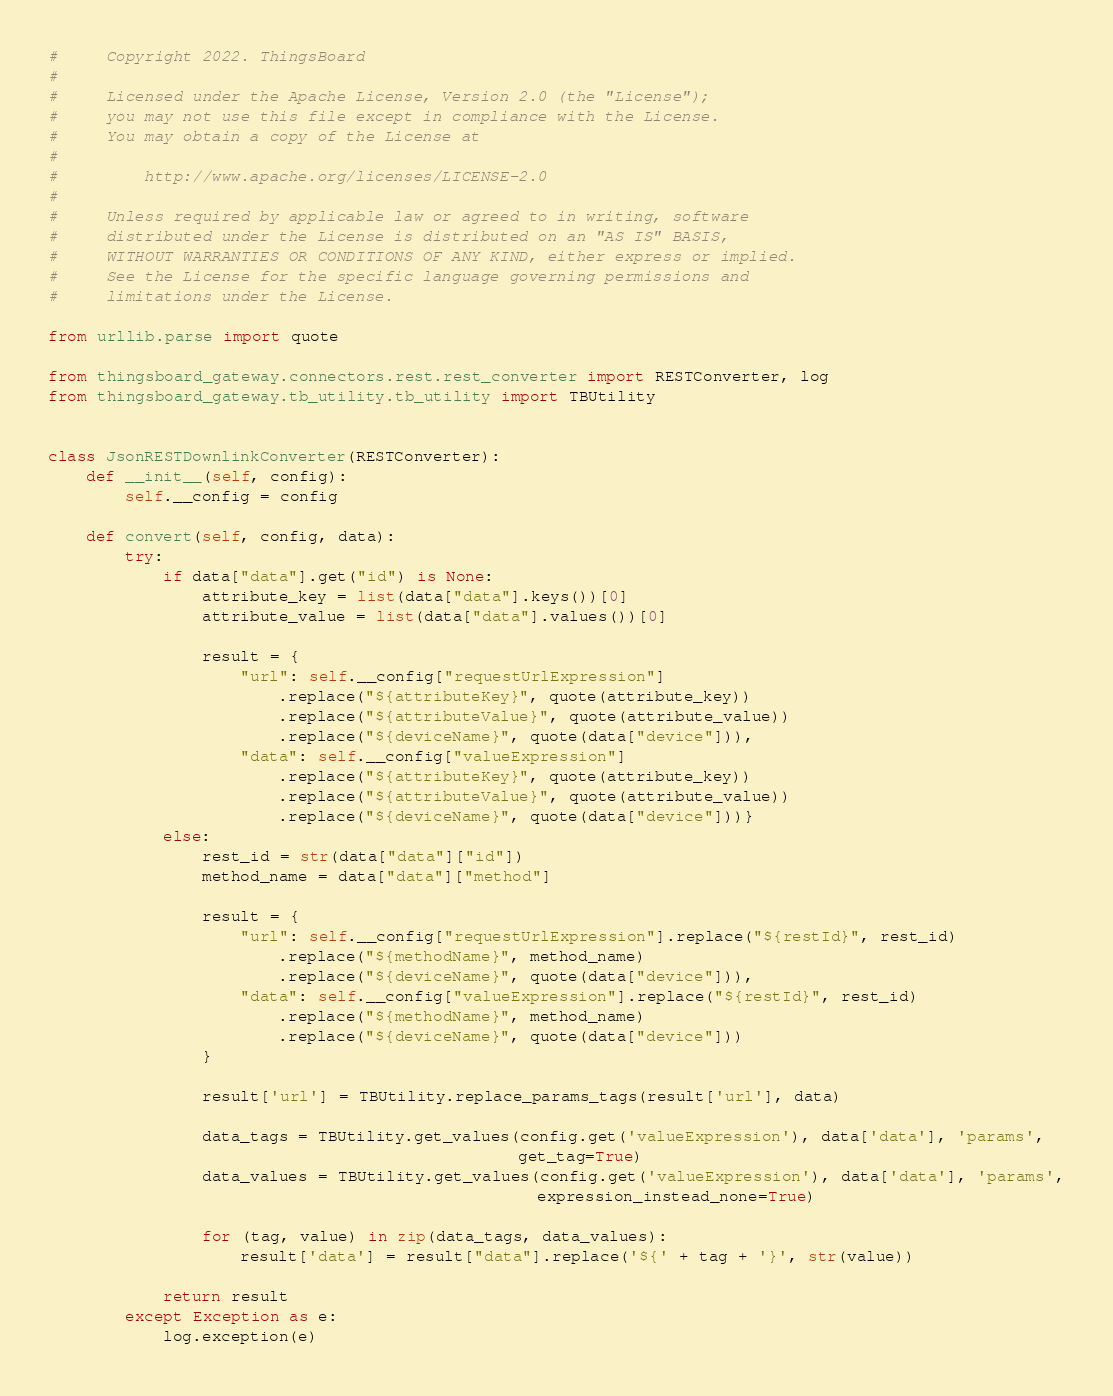Convert code to text. <code><loc_0><loc_0><loc_500><loc_500><_Python_>#     Copyright 2022. ThingsBoard
#
#     Licensed under the Apache License, Version 2.0 (the "License");
#     you may not use this file except in compliance with the License.
#     You may obtain a copy of the License at
#
#         http://www.apache.org/licenses/LICENSE-2.0
#
#     Unless required by applicable law or agreed to in writing, software
#     distributed under the License is distributed on an "AS IS" BASIS,
#     WITHOUT WARRANTIES OR CONDITIONS OF ANY KIND, either express or implied.
#     See the License for the specific language governing permissions and
#     limitations under the License.

from urllib.parse import quote

from thingsboard_gateway.connectors.rest.rest_converter import RESTConverter, log
from thingsboard_gateway.tb_utility.tb_utility import TBUtility


class JsonRESTDownlinkConverter(RESTConverter):
    def __init__(self, config):
        self.__config = config

    def convert(self, config, data):
        try:
            if data["data"].get("id") is None:
                attribute_key = list(data["data"].keys())[0]
                attribute_value = list(data["data"].values())[0]

                result = {
                    "url": self.__config["requestUrlExpression"]
                        .replace("${attributeKey}", quote(attribute_key))
                        .replace("${attributeValue}", quote(attribute_value))
                        .replace("${deviceName}", quote(data["device"])),
                    "data": self.__config["valueExpression"]
                        .replace("${attributeKey}", quote(attribute_key))
                        .replace("${attributeValue}", quote(attribute_value))
                        .replace("${deviceName}", quote(data["device"]))}
            else:
                rest_id = str(data["data"]["id"])
                method_name = data["data"]["method"]

                result = {
                    "url": self.__config["requestUrlExpression"].replace("${restId}", rest_id)
                        .replace("${methodName}", method_name)
                        .replace("${deviceName}", quote(data["device"])),
                    "data": self.__config["valueExpression"].replace("${restId}", rest_id)
                        .replace("${methodName}", method_name)
                        .replace("${deviceName}", quote(data["device"]))
                }

                result['url'] = TBUtility.replace_params_tags(result['url'], data)

                data_tags = TBUtility.get_values(config.get('valueExpression'), data['data'], 'params',
                                                 get_tag=True)
                data_values = TBUtility.get_values(config.get('valueExpression'), data['data'], 'params',
                                                   expression_instead_none=True)

                for (tag, value) in zip(data_tags, data_values):
                    result['data'] = result["data"].replace('${' + tag + '}', str(value))

            return result
        except Exception as e:
            log.exception(e)
</code> 